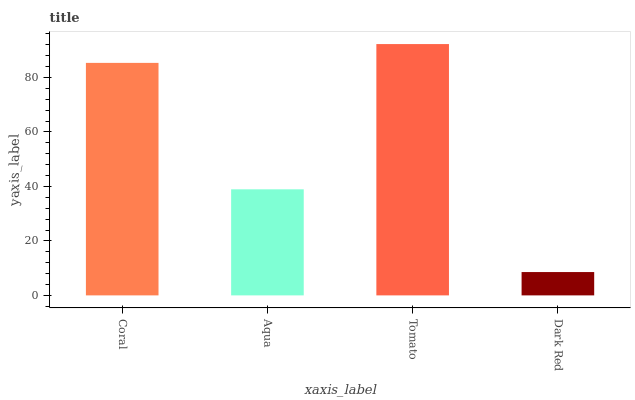Is Dark Red the minimum?
Answer yes or no. Yes. Is Tomato the maximum?
Answer yes or no. Yes. Is Aqua the minimum?
Answer yes or no. No. Is Aqua the maximum?
Answer yes or no. No. Is Coral greater than Aqua?
Answer yes or no. Yes. Is Aqua less than Coral?
Answer yes or no. Yes. Is Aqua greater than Coral?
Answer yes or no. No. Is Coral less than Aqua?
Answer yes or no. No. Is Coral the high median?
Answer yes or no. Yes. Is Aqua the low median?
Answer yes or no. Yes. Is Aqua the high median?
Answer yes or no. No. Is Tomato the low median?
Answer yes or no. No. 